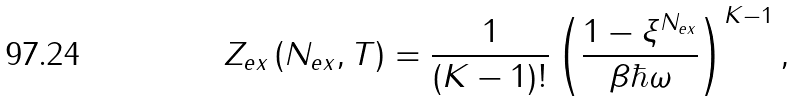Convert formula to latex. <formula><loc_0><loc_0><loc_500><loc_500>Z _ { e x } \left ( N _ { e x } , T \right ) = \frac { 1 } { ( K - 1 ) ! } \left ( \frac { 1 - \xi ^ { N _ { e x } } } { \beta \hbar { \omega } } \right ) ^ { K - 1 } ,</formula> 